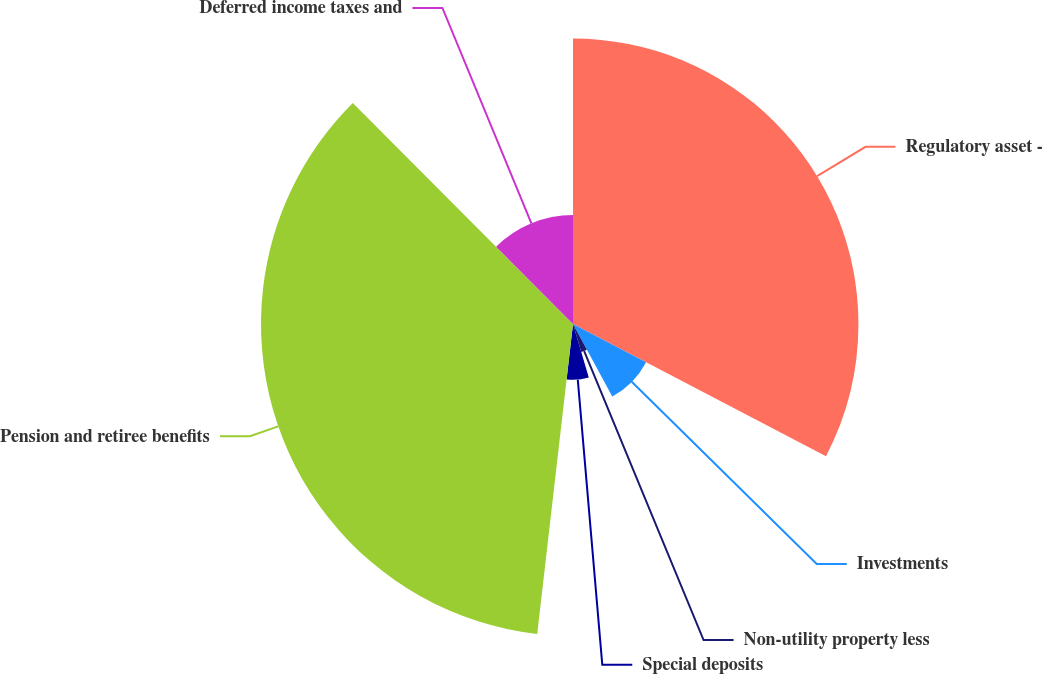<chart> <loc_0><loc_0><loc_500><loc_500><pie_chart><fcel>Regulatory asset -<fcel>Investments<fcel>Non-utility property less<fcel>Special deposits<fcel>Pension and retiree benefits<fcel>Deferred income taxes and<nl><fcel>32.66%<fcel>9.43%<fcel>3.35%<fcel>6.39%<fcel>35.7%<fcel>12.47%<nl></chart> 